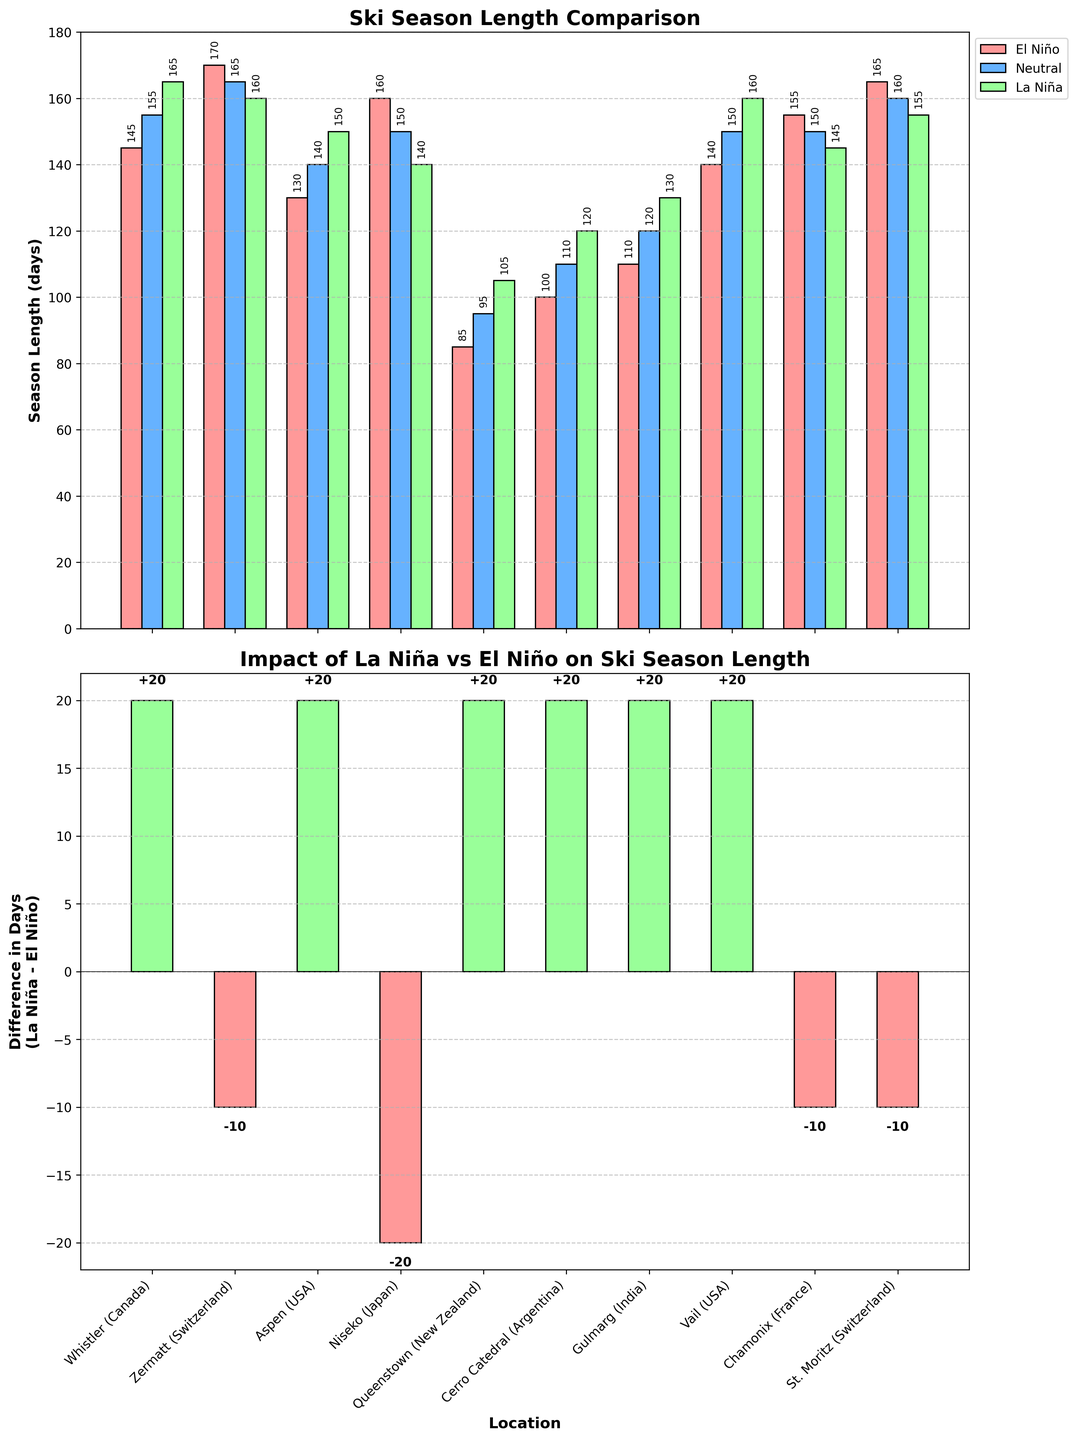What is the title of the top subplot? The title is displayed at the top of the first subplot. It reads "Ski Season Length Comparison", which summarizes the visualized data.
Answer: Ski Season Length Comparison Which location has the shortest ski season length during El Niño events? By examining the height of the bars in the El Niño category for each location, Queenstown (New Zealand) has the shortest bar, representing its season length.
Answer: Queenstown (New Zealand) What is the difference in ski season length between La Niña and El Niño cycles for Chamonix (France)? Locate Chamonix (France) in the bottom subplot which shows the differences. The bar length for Chamonix indicates the difference directly.
Answer: -10 days For which location is the ski season length longer during La Niña compared to Neutral periods? Investigate which locations have taller La Niña bars compared to Neutral bars in the first subplot. For Zermatt (Switzerland) and Vail (USA), La Niña season lengths are longer.
Answer: Zermatt (Switzerland) and Vail (USA) What is the median value of the ski season length during Neutral periods? List all the Neutral season lengths: 155, 165, 140, 150, 95, 110, 120, 150, 150, 160. Ordered: 95, 110, 120, 140, 150, 150, 155, 160, 165. Median is the average of 5th and 6th values.
Answer: 150 days Which location experiences the highest increase in ski season length during La Niña compared to El Niño events? In the bottom subplot, identify the location with the longest upward bar, which represents the highest positive difference.
Answer: Gulmarg (India) What is the combined average ski season length for Whistler (Canada) over all climate cycles? Add lengths for all periods and divide by the number of periods for Whistler: (145 + 165 + 155) / 3.
Answer: 155 days Between Aspen (USA) and St. Moritz (Switzerland), which location has a more significant decrease in ski season length from El Niño to Neutral periods? Compare the bar heights for El Niño and Neutral periods for both locations. Aspen drops more significantly from 130 to 140, while St. Moritz drops from 165 to 160.
Answer: Aspen (USA) Which climate event results in the longest ski season at Cerro Catedral (Argentina)? Compare the heights of the three bars for Cerro Catedral in the first subplot. The tallest is La Niña with 120 days.
Answer: La Niña 